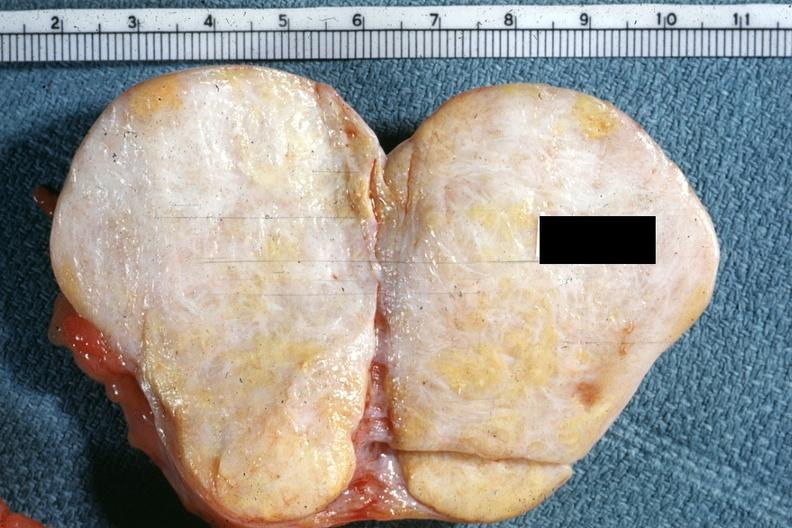s simian crease present?
Answer the question using a single word or phrase. No 